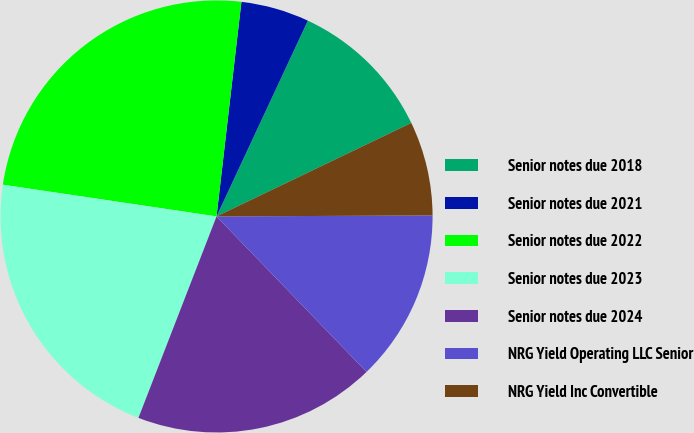Convert chart. <chart><loc_0><loc_0><loc_500><loc_500><pie_chart><fcel>Senior notes due 2018<fcel>Senior notes due 2021<fcel>Senior notes due 2022<fcel>Senior notes due 2023<fcel>Senior notes due 2024<fcel>NRG Yield Operating LLC Senior<fcel>NRG Yield Inc Convertible<nl><fcel>10.93%<fcel>5.11%<fcel>24.49%<fcel>21.46%<fcel>18.1%<fcel>12.86%<fcel>7.05%<nl></chart> 